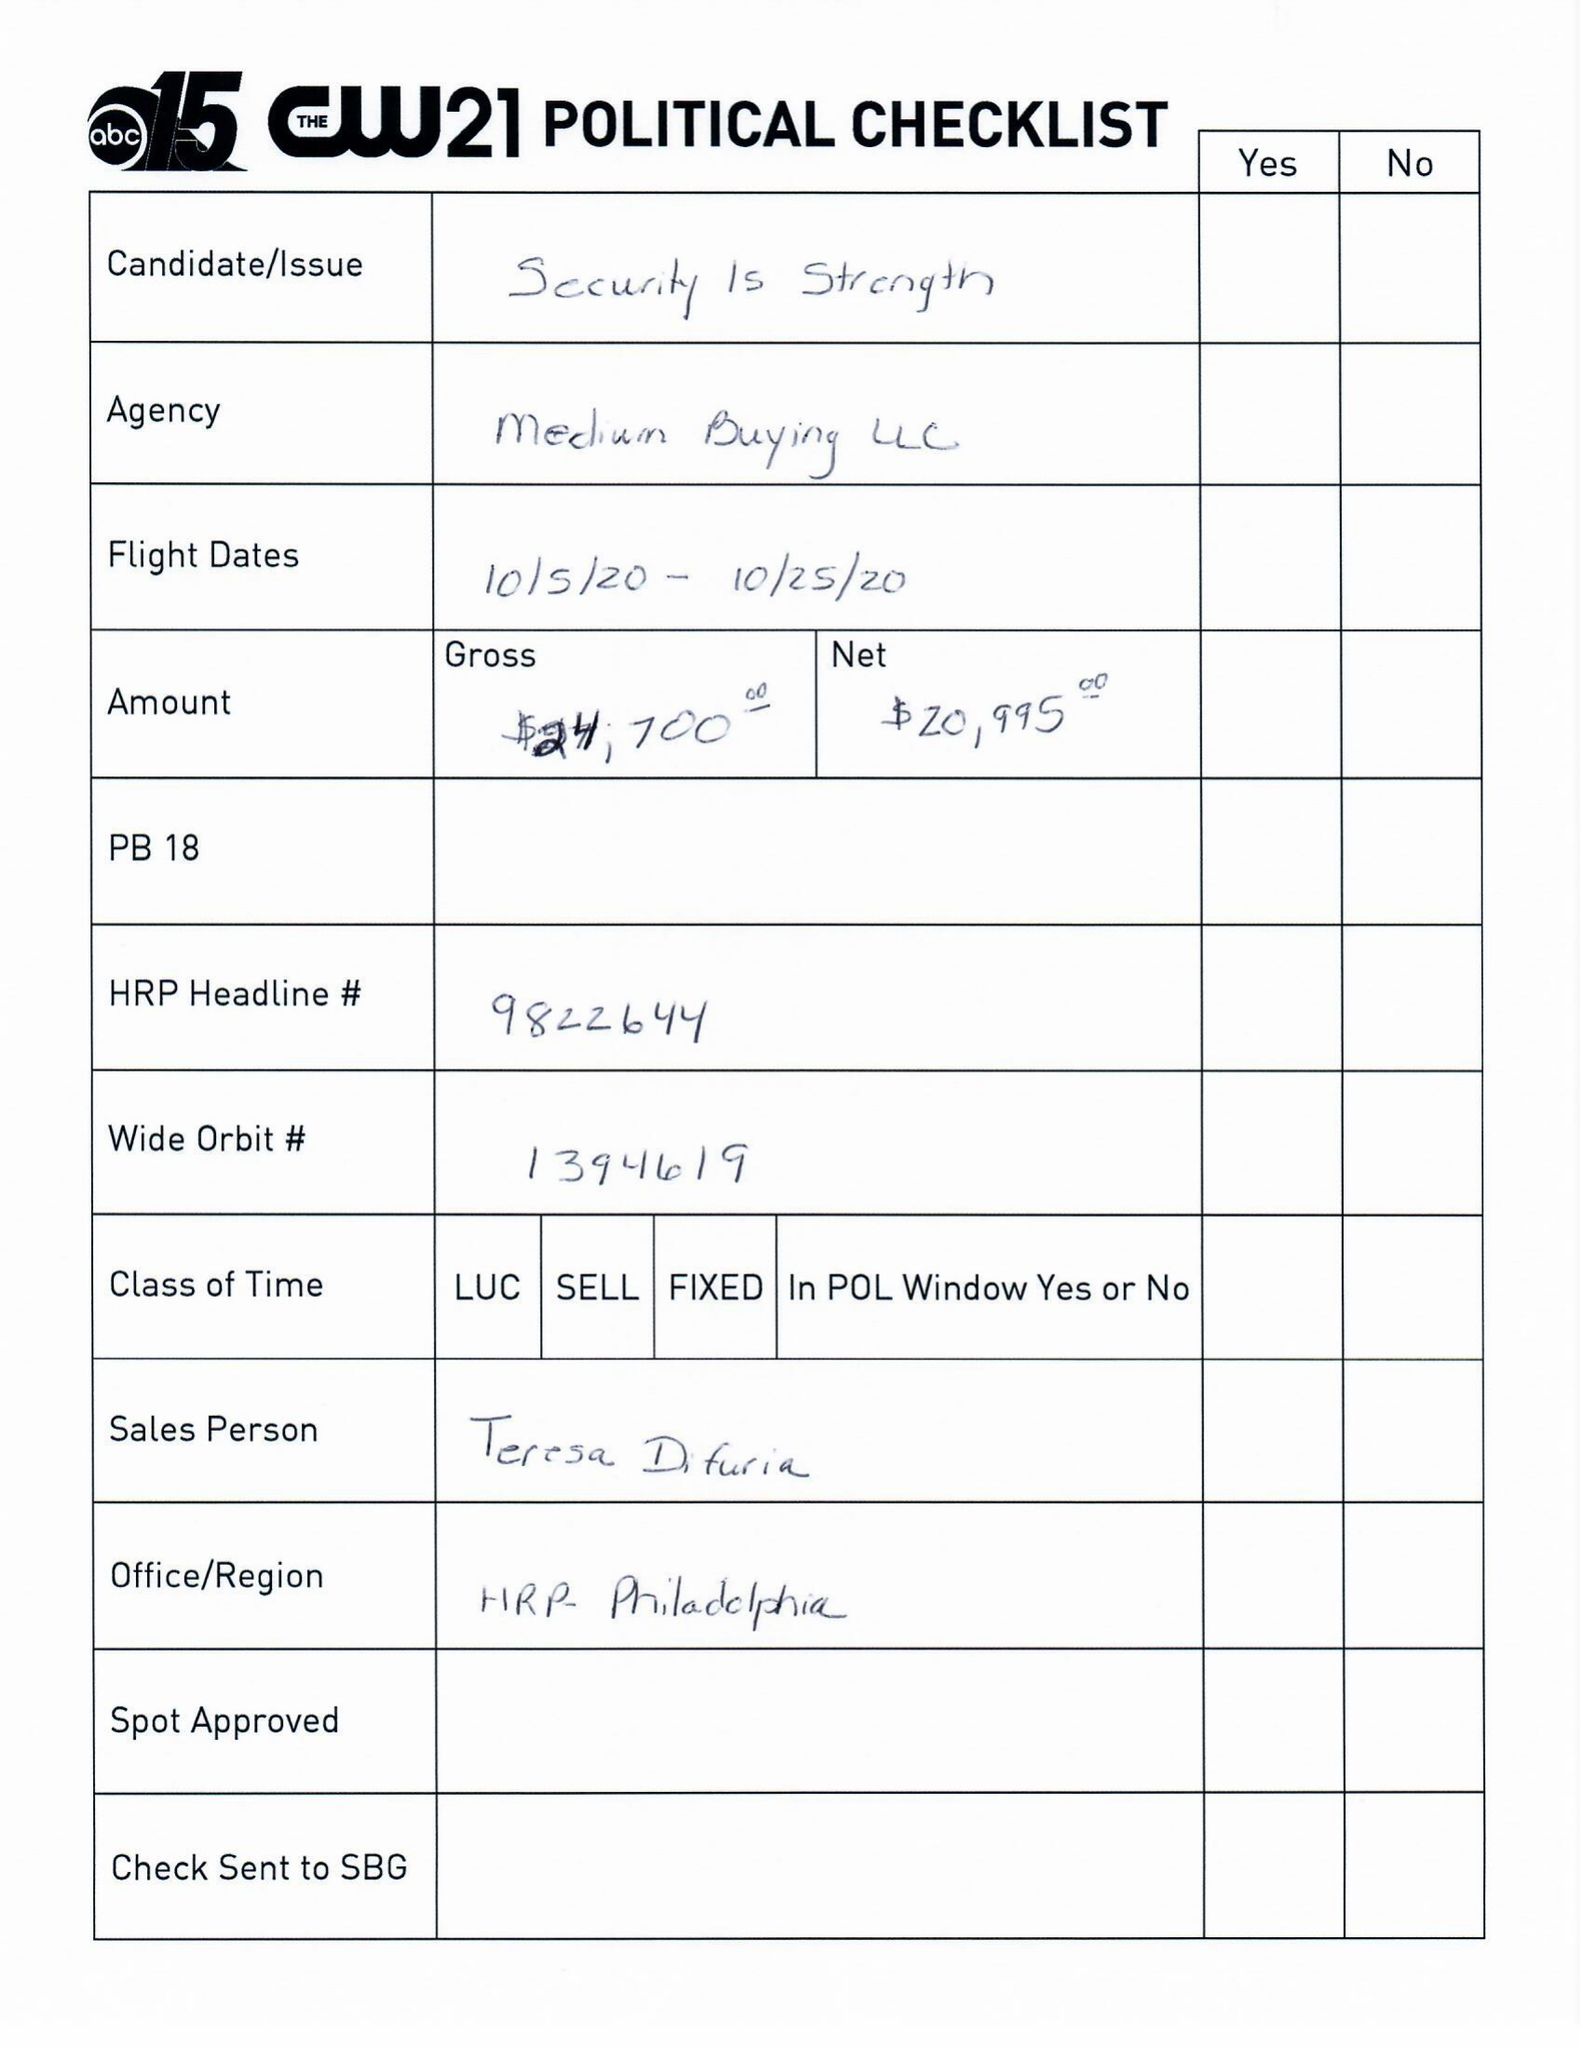What is the value for the flight_from?
Answer the question using a single word or phrase. 10/05/20 